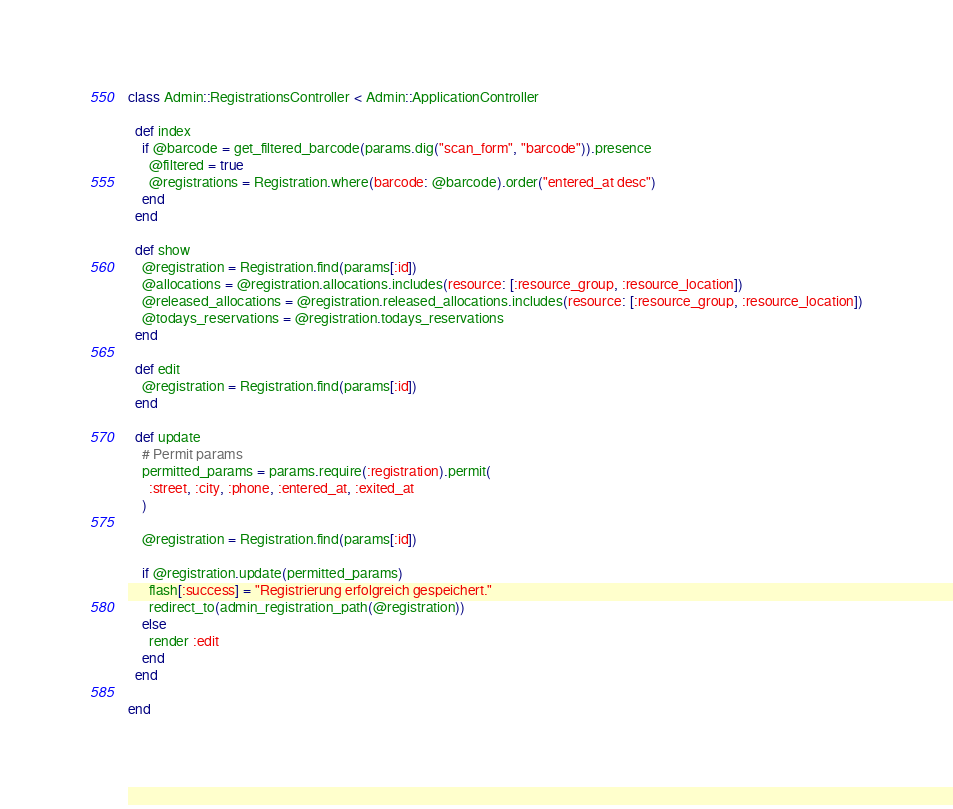Convert code to text. <code><loc_0><loc_0><loc_500><loc_500><_Ruby_>class Admin::RegistrationsController < Admin::ApplicationController

  def index
    if @barcode = get_filtered_barcode(params.dig("scan_form", "barcode")).presence
      @filtered = true
      @registrations = Registration.where(barcode: @barcode).order("entered_at desc")
    end
  end

  def show
    @registration = Registration.find(params[:id])
    @allocations = @registration.allocations.includes(resource: [:resource_group, :resource_location])
    @released_allocations = @registration.released_allocations.includes(resource: [:resource_group, :resource_location])
    @todays_reservations = @registration.todays_reservations
  end

  def edit
    @registration = Registration.find(params[:id])
  end

  def update
    # Permit params
    permitted_params = params.require(:registration).permit(
      :street, :city, :phone, :entered_at, :exited_at
    )

    @registration = Registration.find(params[:id])

    if @registration.update(permitted_params)
      flash[:success] = "Registrierung erfolgreich gespeichert."
      redirect_to(admin_registration_path(@registration))
    else
      render :edit
    end
  end

end
</code> 